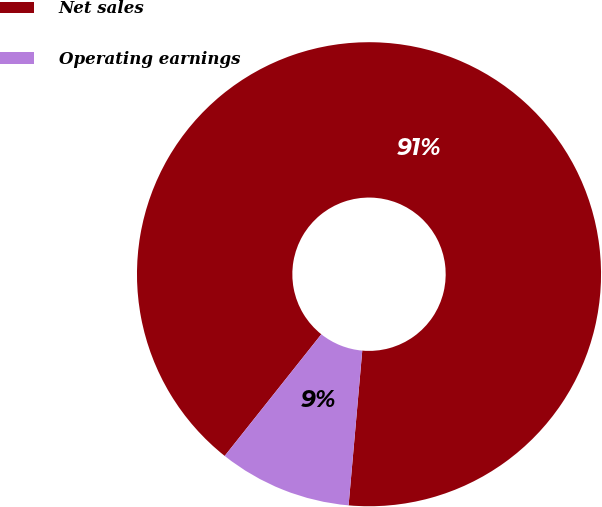Convert chart to OTSL. <chart><loc_0><loc_0><loc_500><loc_500><pie_chart><fcel>Net sales<fcel>Operating earnings<nl><fcel>90.72%<fcel>9.28%<nl></chart> 